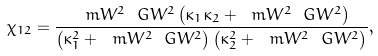Convert formula to latex. <formula><loc_0><loc_0><loc_500><loc_500>\chi _ { 1 2 } = \frac { \ m W ^ { 2 } \ G W ^ { 2 } \left ( \kappa _ { 1 } \kappa _ { 2 } + \ m W ^ { 2 } \ G W ^ { 2 } \right ) } { \left ( \kappa _ { 1 } ^ { 2 } + \ m W ^ { 2 } \ G W ^ { 2 } \right ) \left ( \kappa _ { 2 } ^ { 2 } + \ m W ^ { 2 } \ G W ^ { 2 } \right ) } ,</formula> 